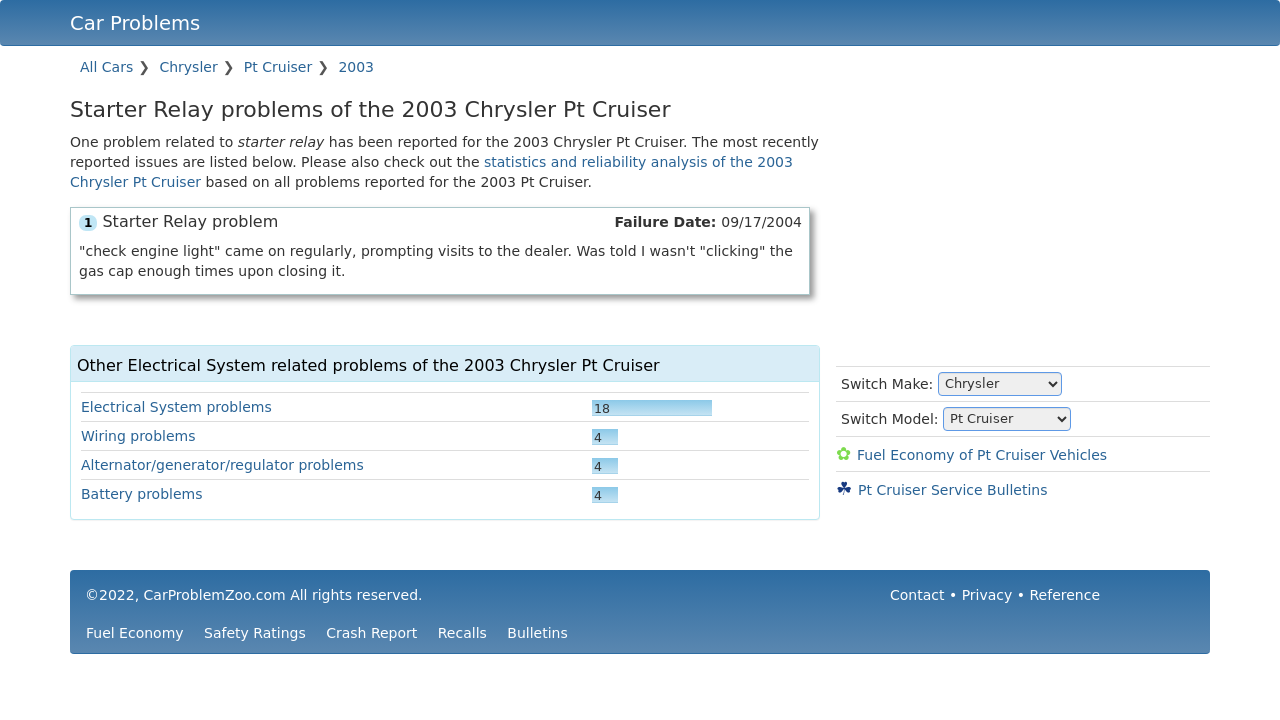What are some common issues reported for the PT Cruiser in other years? Common issues for the PT Cruiser in various years often relate to the electrical system, suspension, and engine performance. Specific problems reported frequently include faulty wiring, issues with the powertrain, and recurrent failures in the suspension system.  Which model year of the PT Cruiser is considered the most reliable? The 2010 PT Cruiser model is often considered more reliable compared to other years, having fewer reports of severe mechanical issues and recalls. It marks the last production year for the model, featuring refinements from earlier versions. 